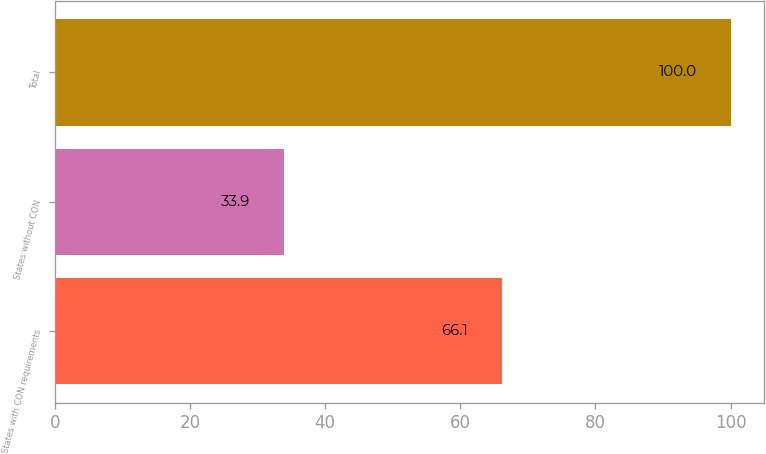<chart> <loc_0><loc_0><loc_500><loc_500><bar_chart><fcel>States with CON requirements<fcel>States without CON<fcel>Total<nl><fcel>66.1<fcel>33.9<fcel>100<nl></chart> 